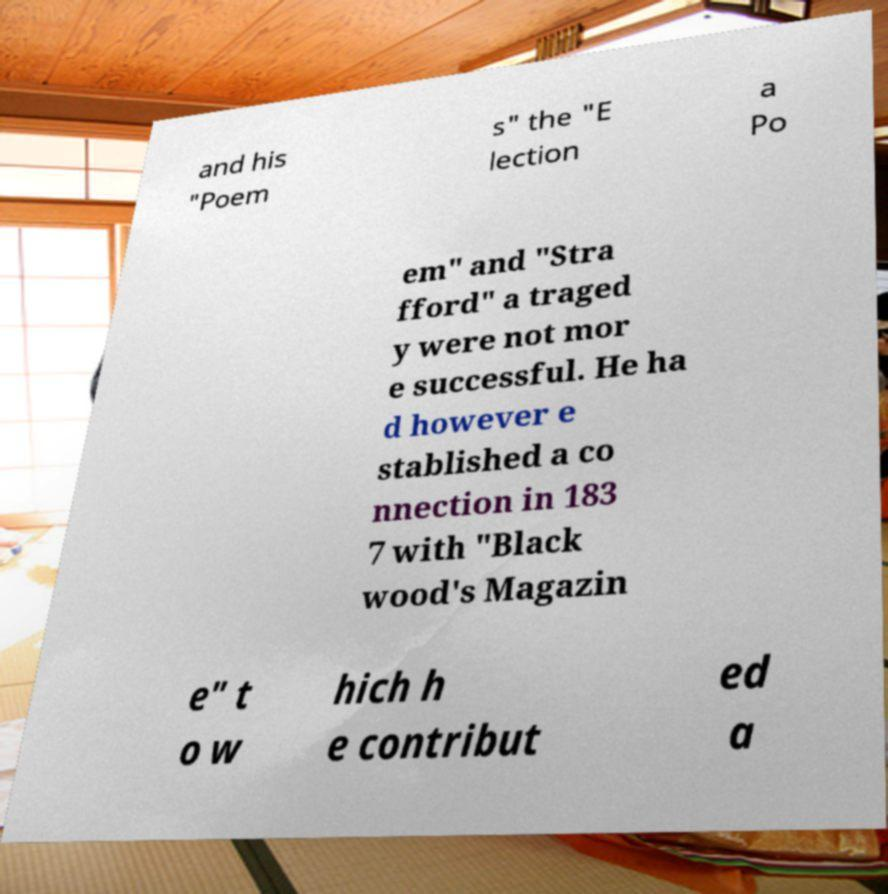Can you read and provide the text displayed in the image?This photo seems to have some interesting text. Can you extract and type it out for me? and his "Poem s" the "E lection a Po em" and "Stra fford" a traged y were not mor e successful. He ha d however e stablished a co nnection in 183 7 with "Black wood's Magazin e" t o w hich h e contribut ed a 